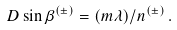Convert formula to latex. <formula><loc_0><loc_0><loc_500><loc_500>D \sin \beta ^ { ( \pm ) } = ( m \lambda ) / n ^ { ( \pm ) } \, .</formula> 